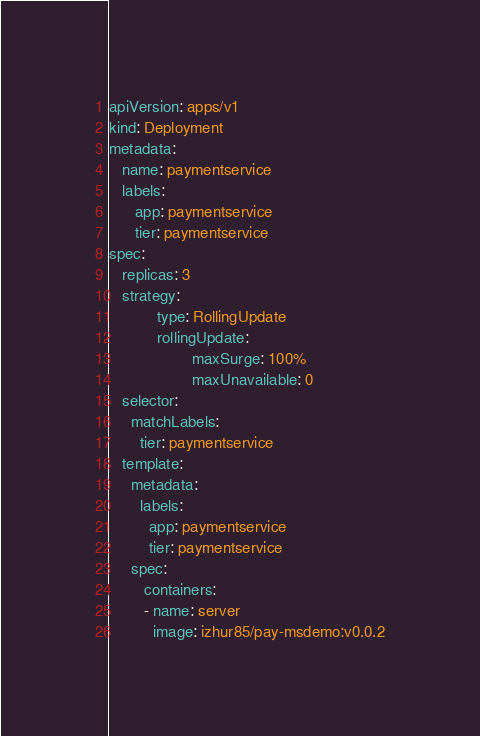<code> <loc_0><loc_0><loc_500><loc_500><_YAML_>apiVersion: apps/v1
kind: Deployment
metadata:
   name: paymentservice
   labels:
      app: paymentservice
      tier: paymentservice
spec:
   replicas: 3
   strategy:
           type: RollingUpdate
           rollingUpdate:
                   maxSurge: 100%
                   maxUnavailable: 0
   selector:
     matchLabels:
       tier: paymentservice      
   template:
     metadata:
       labels:
         app: paymentservice
         tier: paymentservice
     spec:
        containers:
        - name: server
          image: izhur85/pay-msdemo:v0.0.2
</code> 